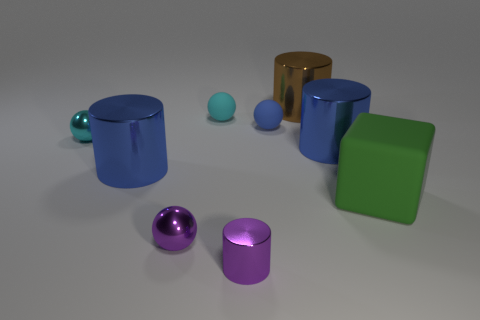Does the small metallic cylinder have the same color as the tiny sphere in front of the big green thing?
Provide a succinct answer. Yes. What material is the blue thing that is the same size as the cyan shiny thing?
Your answer should be compact. Rubber. How many things are either brown cylinders or blue cylinders that are to the left of the tiny cyan matte thing?
Your answer should be compact. 2. There is a purple cylinder; is it the same size as the brown cylinder that is behind the green rubber object?
Give a very brief answer. No. How many spheres are either blue objects or small blue rubber things?
Ensure brevity in your answer.  1. What number of objects are both on the left side of the small purple cylinder and in front of the green rubber cube?
Your response must be concise. 1. How many other objects are the same color as the cube?
Keep it short and to the point. 0. The matte thing right of the big brown metallic thing has what shape?
Give a very brief answer. Cube. Are the small cylinder and the brown cylinder made of the same material?
Ensure brevity in your answer.  Yes. Are there any other things that are the same size as the blue ball?
Offer a terse response. Yes. 